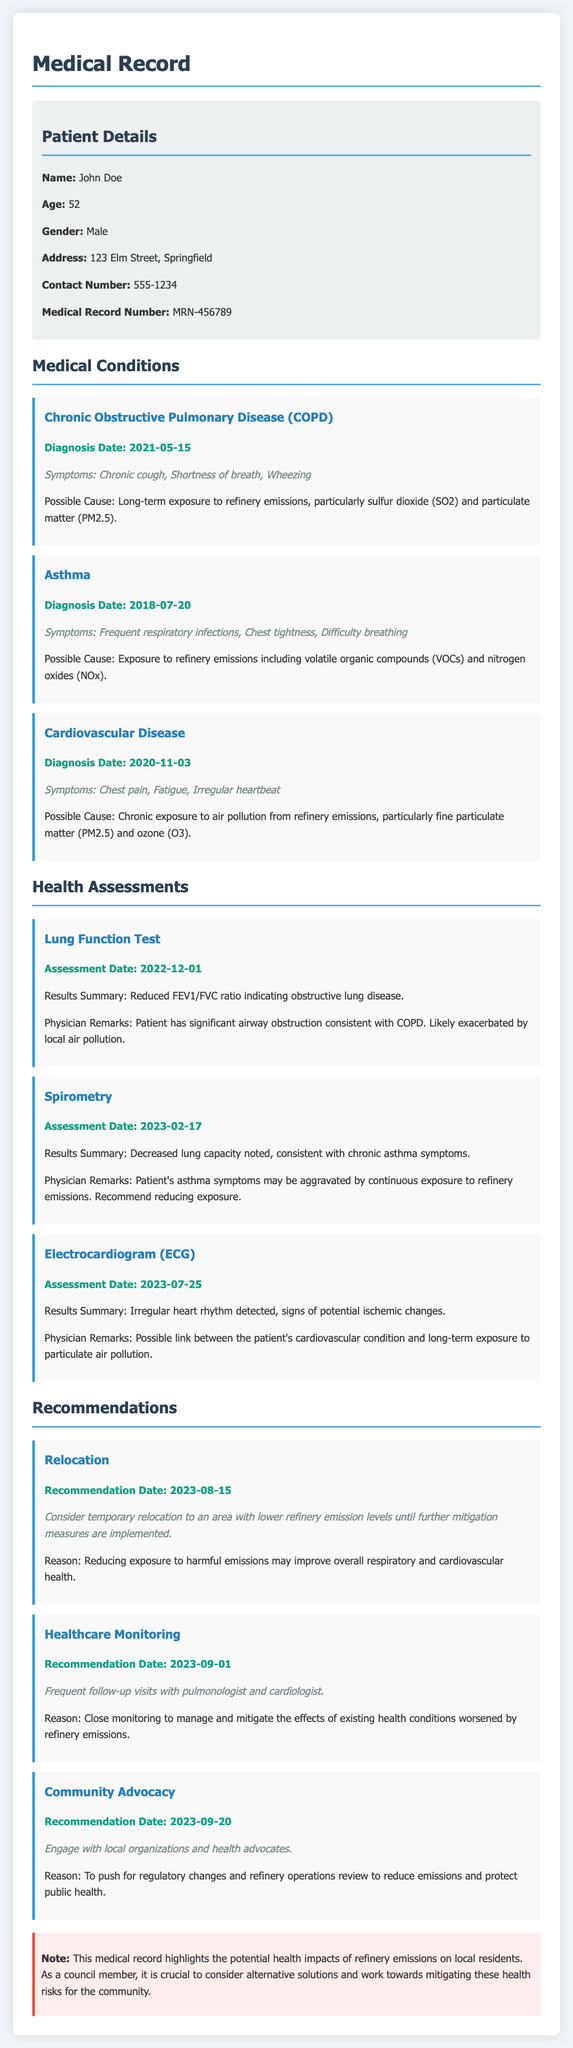What is the patient's name? The patient's name is mentioned in the patient details section.
Answer: John Doe What is the diagnosis date for Chronic Obstructive Pulmonary Disease? The diagnosis date for this condition is stated within the condition section.
Answer: 2021-05-15 What symptoms are associated with Asthma? Symptoms for Asthma are listed in the condition section.
Answer: Frequent respiratory infections, Chest tightness, Difficulty breathing What were the results of the Lung Function Test? The results summary for the Lung Function Test is provided in the health assessments section.
Answer: Reduced FEV1/FVC ratio indicating obstructive lung disease How many health assessments are mentioned? The number of health assessments can be counted from the respective section of the document.
Answer: Three What is a recommended course of action for relocation? The recommendation section outlines a specific suggested action regarding relocation.
Answer: Consider temporary relocation to an area with lower refinery emission levels What is a noted possible link to the patient's cardiovascular condition? The potential link is highlighted in the assessment section related to the ECG results.
Answer: Long-term exposure to particulate air pollution What is one reason for community advocacy mentioned? The reason for community advocacy is detailed within the recommendations section.
Answer: To push for regulatory changes and refinery operations review to reduce emissions 